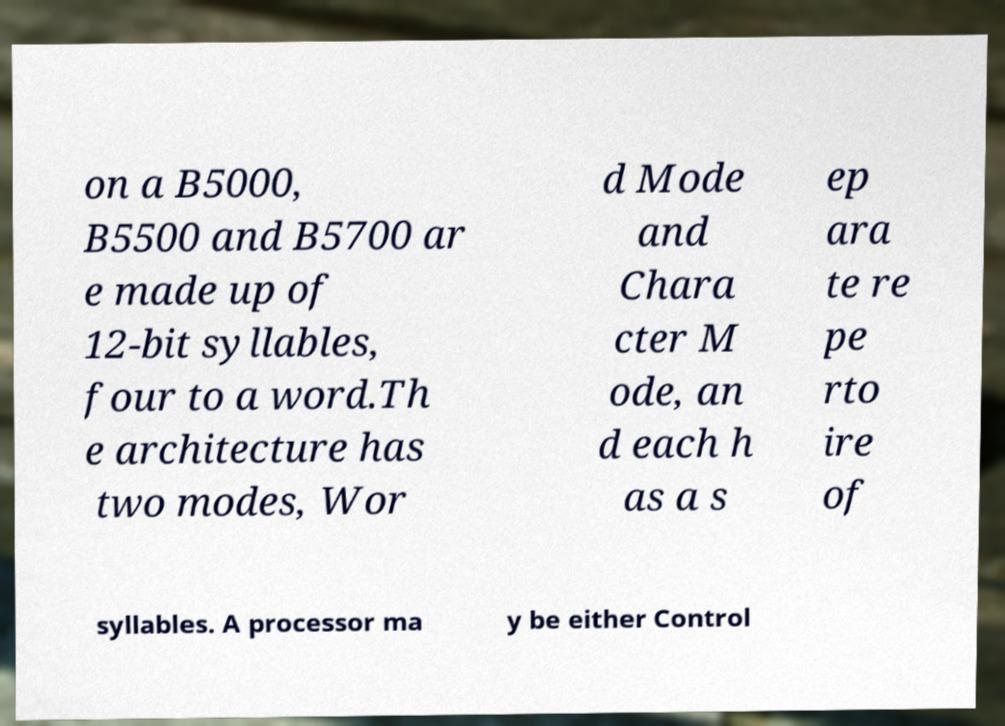Please read and relay the text visible in this image. What does it say? on a B5000, B5500 and B5700 ar e made up of 12-bit syllables, four to a word.Th e architecture has two modes, Wor d Mode and Chara cter M ode, an d each h as a s ep ara te re pe rto ire of syllables. A processor ma y be either Control 